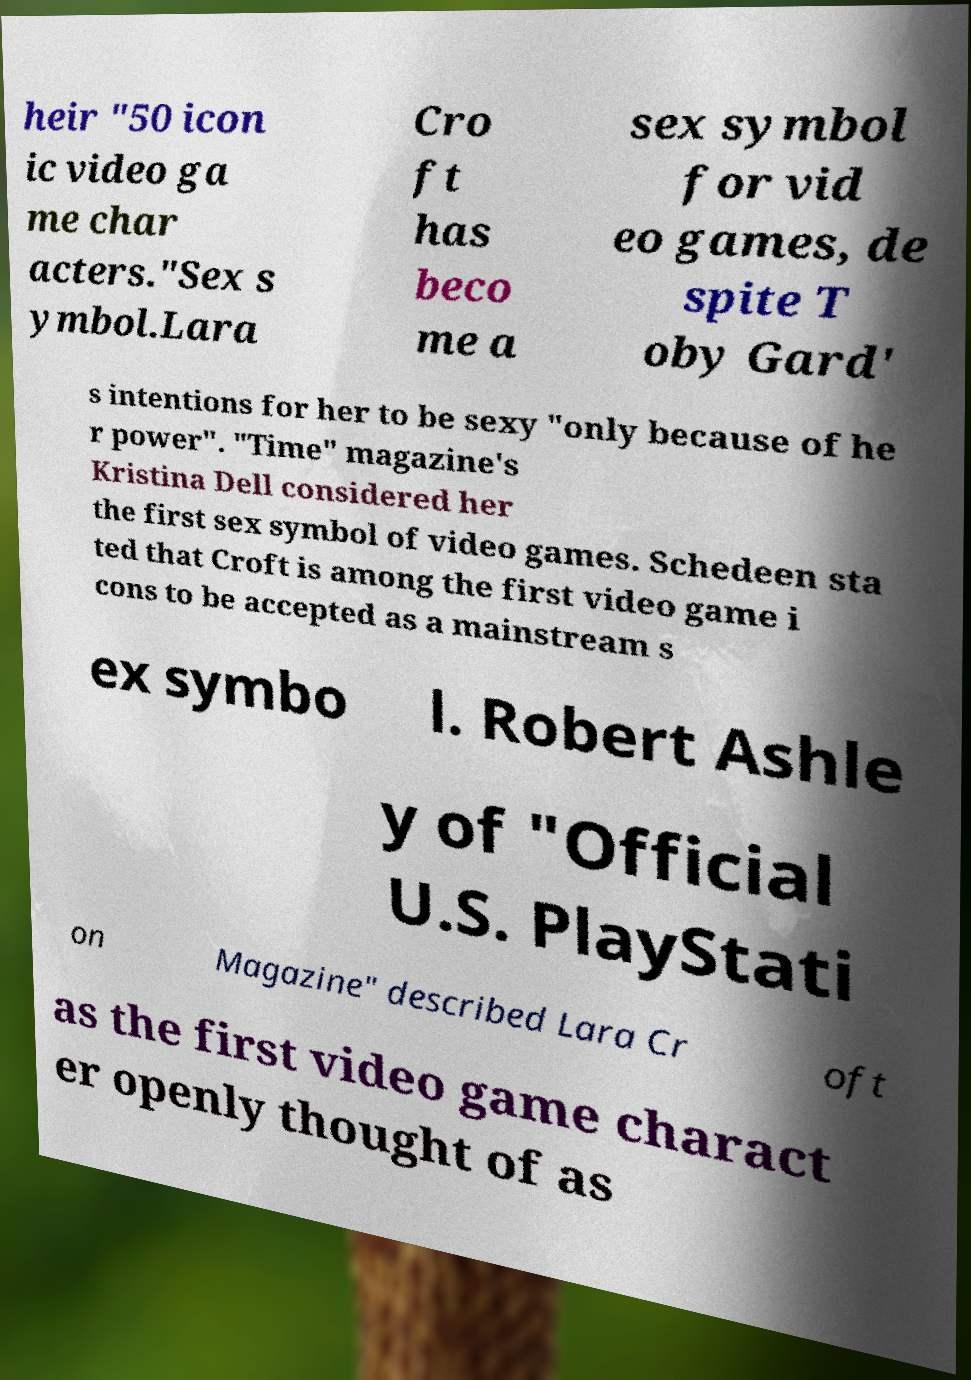Could you extract and type out the text from this image? heir "50 icon ic video ga me char acters."Sex s ymbol.Lara Cro ft has beco me a sex symbol for vid eo games, de spite T oby Gard' s intentions for her to be sexy "only because of he r power". "Time" magazine's Kristina Dell considered her the first sex symbol of video games. Schedeen sta ted that Croft is among the first video game i cons to be accepted as a mainstream s ex symbo l. Robert Ashle y of "Official U.S. PlayStati on Magazine" described Lara Cr oft as the first video game charact er openly thought of as 